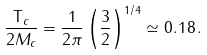<formula> <loc_0><loc_0><loc_500><loc_500>\frac { { \mathsf T } _ { c } } { 2 M _ { c } } = \frac { 1 } { 2 \pi } \left ( \frac { 3 } { 2 } \right ) ^ { 1 / 4 } \simeq 0 . 1 8 \, .</formula> 